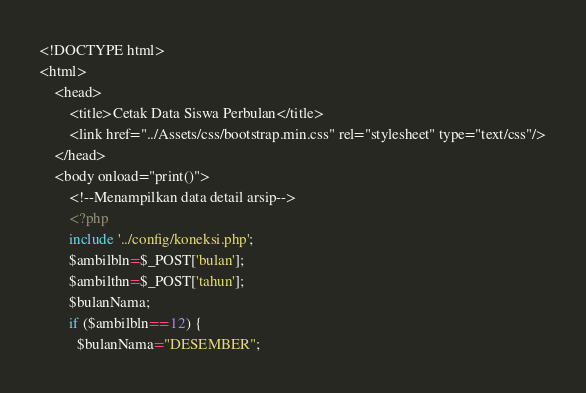Convert code to text. <code><loc_0><loc_0><loc_500><loc_500><_PHP_><!DOCTYPE html>
<html>
    <head>
        <title>Cetak Data Siswa Perbulan</title>
        <link href="../Assets/css/bootstrap.min.css" rel="stylesheet" type="text/css"/>
    </head>
    <body onload="print()">
        <!--Menampilkan data detail arsip-->
        <?php
        include '../config/koneksi.php';
        $ambilbln=$_POST['bulan'];
        $ambilthn=$_POST['tahun'];
        $bulanNama;
        if ($ambilbln==12) {
          $bulanNama="DESEMBER";</code> 